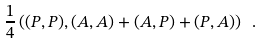<formula> <loc_0><loc_0><loc_500><loc_500>\frac { 1 } { 4 } \left ( ( P , P ) , ( A , A ) + ( A , P ) + ( P , A ) \right ) \ .</formula> 